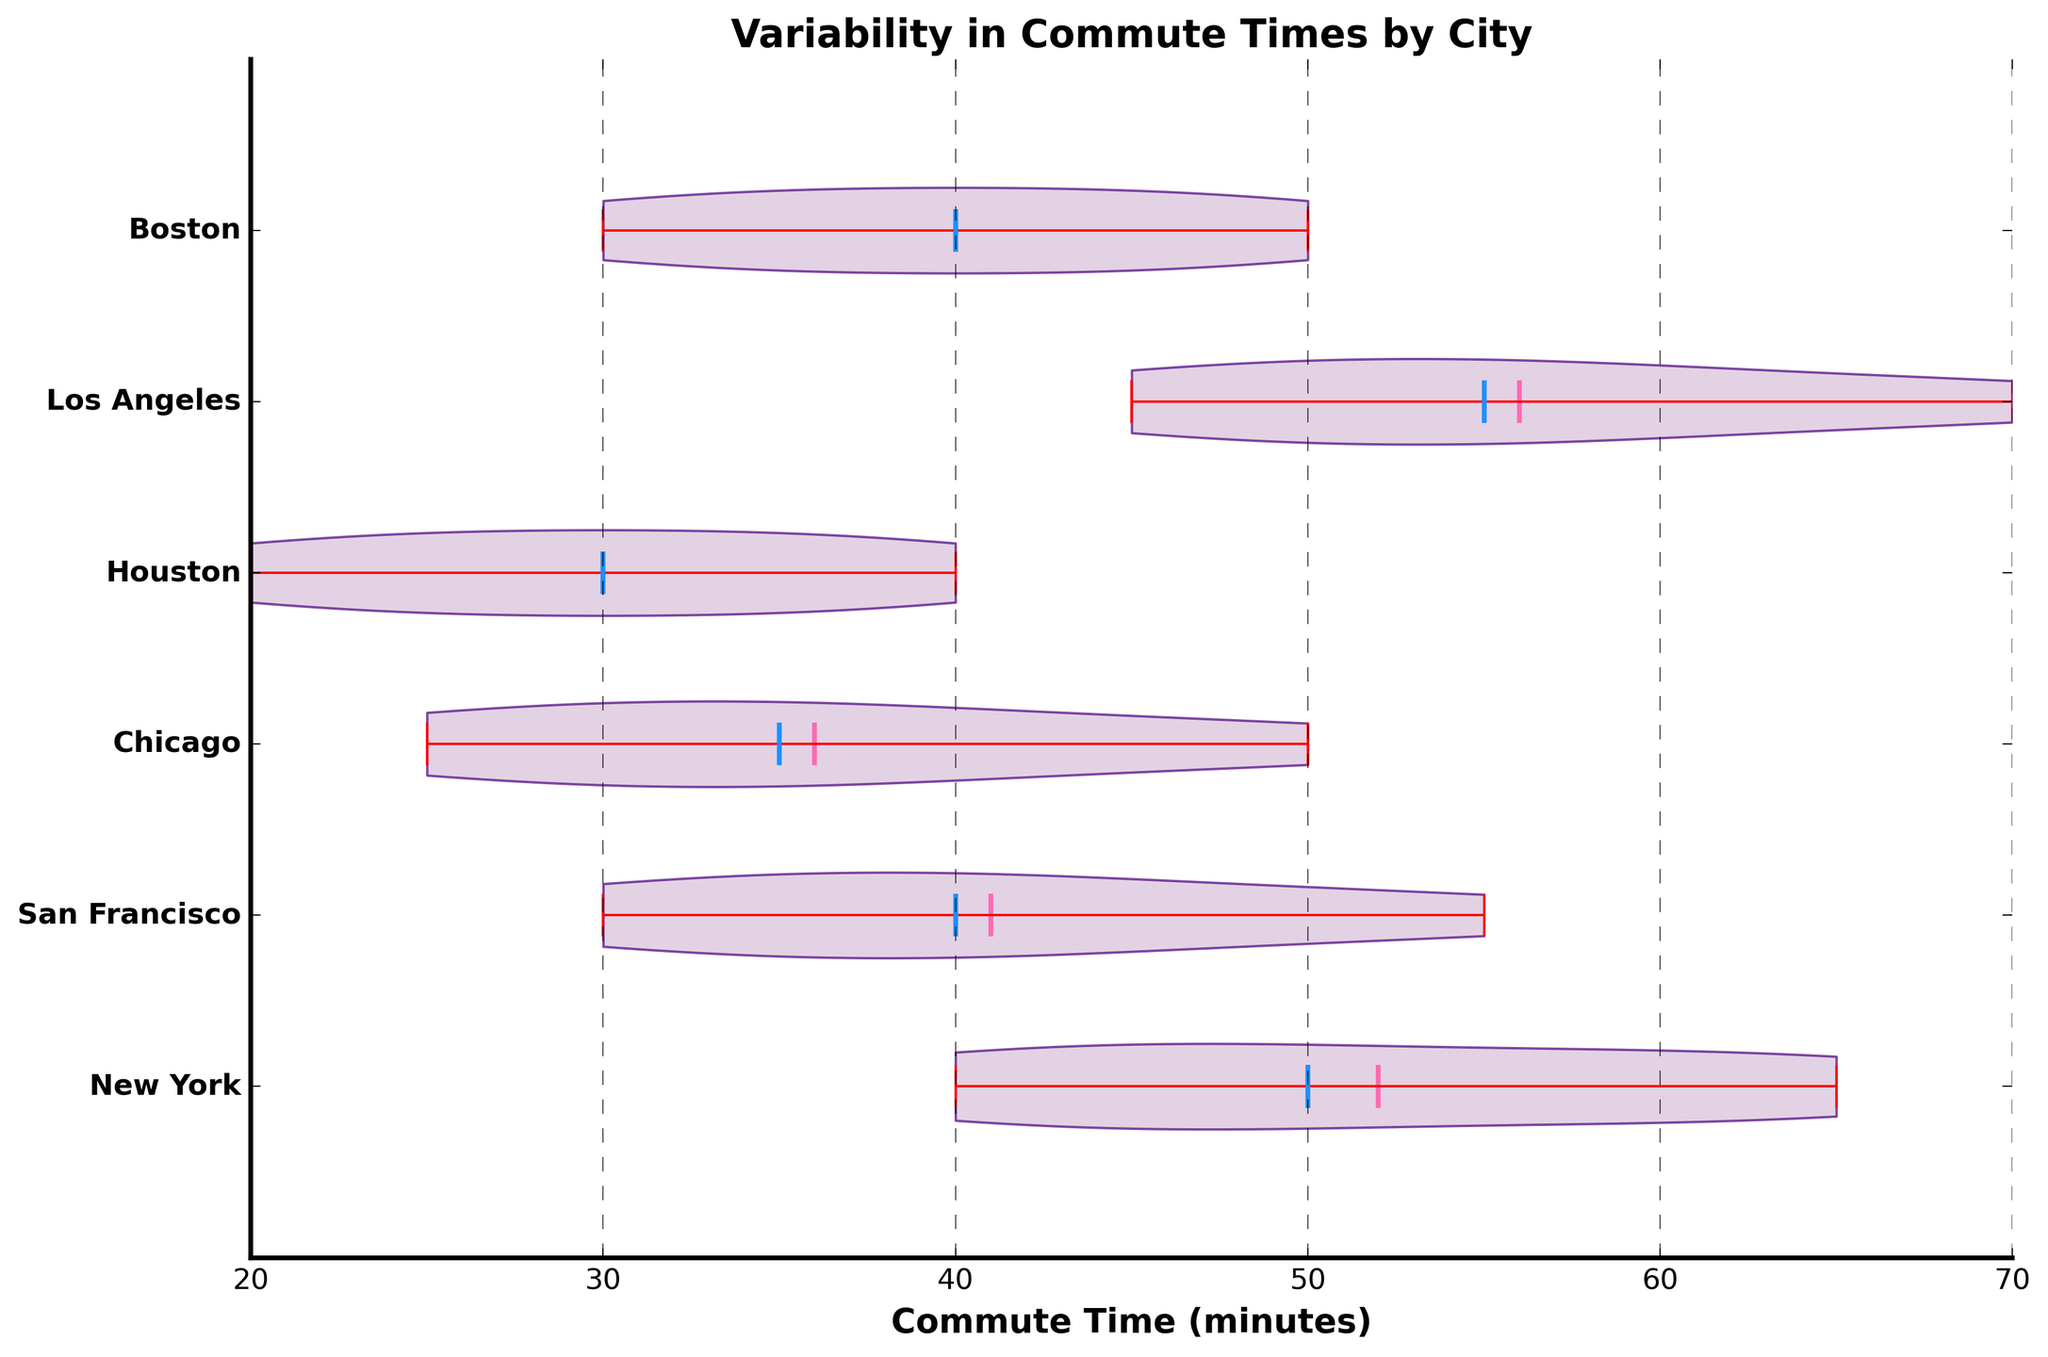Which city has the highest median commute time? From the figure, identify the horizontal line in each violin plot that represents the median. The city with the highest positioned median line along the x-axis is the one with the highest median commute time.
Answer: Los Angeles What is the title of the figure? The title is displayed at the top of the figure and summarizes what the chart is about.
Answer: Variability in Commute Times by City Which two cities have the most similar mean commute time? Look for the pink horizontal lines, which denote the mean commute times, that are closest together on the x-axis.
Answer: New York and Los Angeles What color represents the median commute time in the figure? Observe the figure and identify the color of the horizontal line in the middle of each violin plot.
Answer: Blue How does the range of commute times in San Francisco compare to that in Houston? Compare the widths (ranges) of the violin plots for San Francisco and Houston by looking at the most extended horizontal points of each plot.
Answer: San Francisco has a wider range than Houston Which city has the lowest maximum commute time? Check the highest points depicted within the violin plots for each city along the x-axis, and identify which one reaches the least far to the right.
Answer: Houston How do the commute times trend across the cities from Houston to Los Angeles? Identify the overall shape and spread of the violin plots from left to right, noting any overall trends in central tendency and spread.
Answer: Commute times generally increase from Houston to Los Angeles What is the mean commute time for Boston? Find the pink horizontal line within the Boston violin plot and read off its position along the x-axis.
Answer: 40 minutes Which city has the most symmetrical distribution of commute times? Look for the violin plot that appears most evenly balanced around its center vertical axis, indicating symmetry in the distribution.
Answer: Chicago 